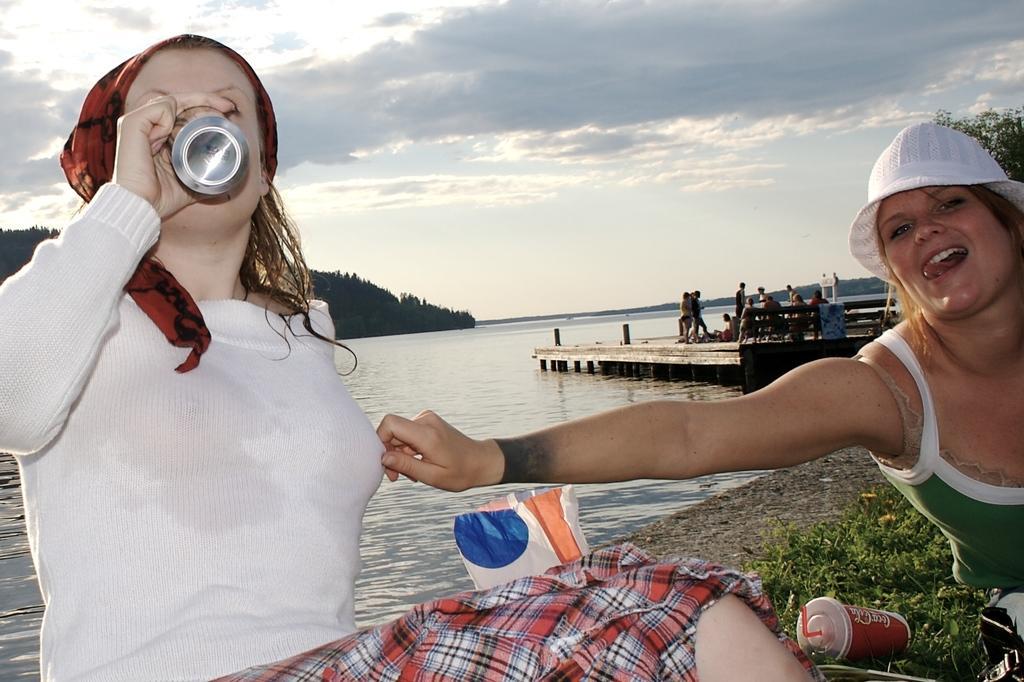Please provide a concise description of this image. In this image we can see two women sitting on the grass. In that a woman is drinking a coke. We can also see a coke tin and a cover beside them. On the backside we can see a group of people standing on the bridge. We can also see a water body, trees on the hill and the sky which looks cloudy. 